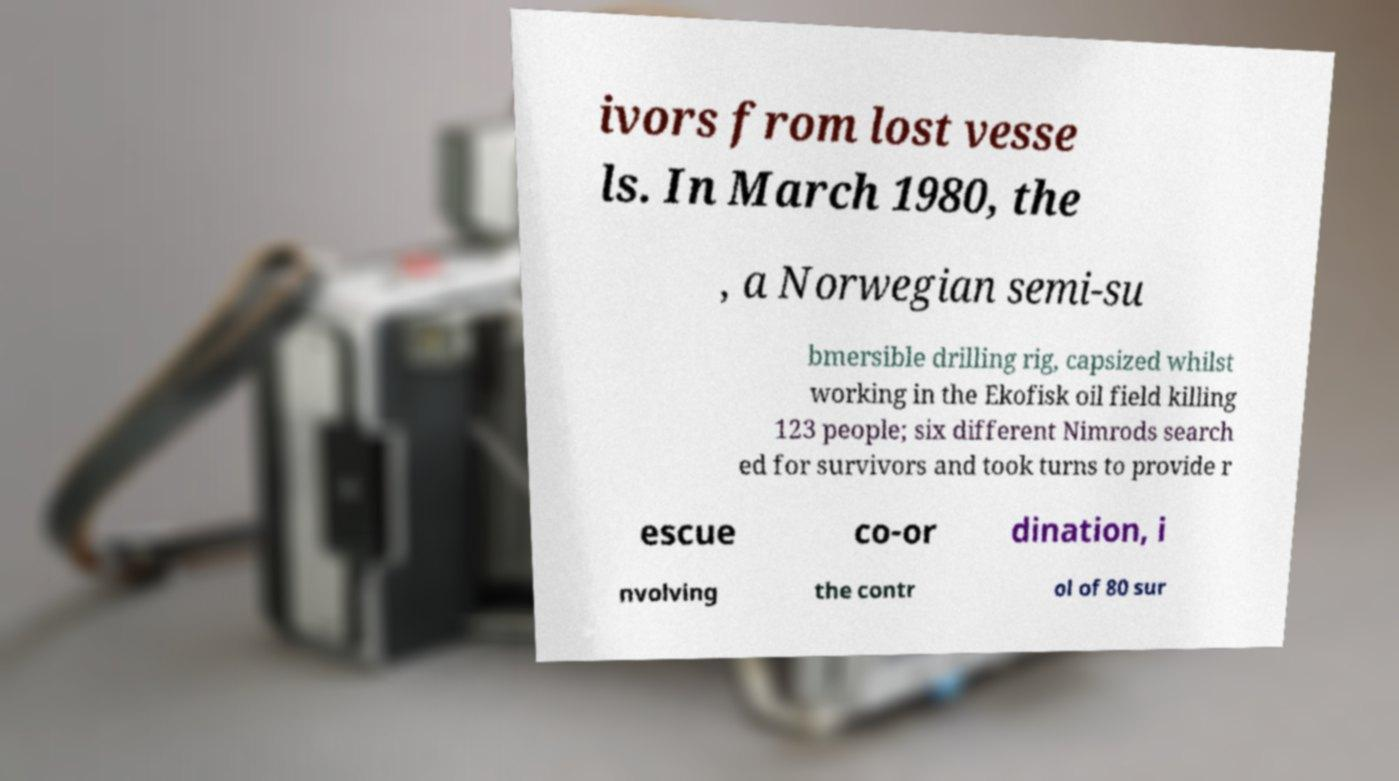What messages or text are displayed in this image? I need them in a readable, typed format. ivors from lost vesse ls. In March 1980, the , a Norwegian semi-su bmersible drilling rig, capsized whilst working in the Ekofisk oil field killing 123 people; six different Nimrods search ed for survivors and took turns to provide r escue co-or dination, i nvolving the contr ol of 80 sur 